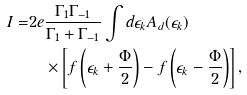<formula> <loc_0><loc_0><loc_500><loc_500>I = & 2 e \frac { \Gamma _ { 1 } \Gamma _ { - 1 } } { \Gamma _ { 1 } + \Gamma _ { - 1 } } \int d \epsilon _ { k } A _ { d } ( \epsilon _ { k } ) \\ & \quad \times \left [ f \left ( { \epsilon _ { k } + \frac { \Phi } { 2 } } \right ) - f \left ( { \epsilon _ { k } - \frac { \Phi } { 2 } } \right ) \right ] ,</formula> 